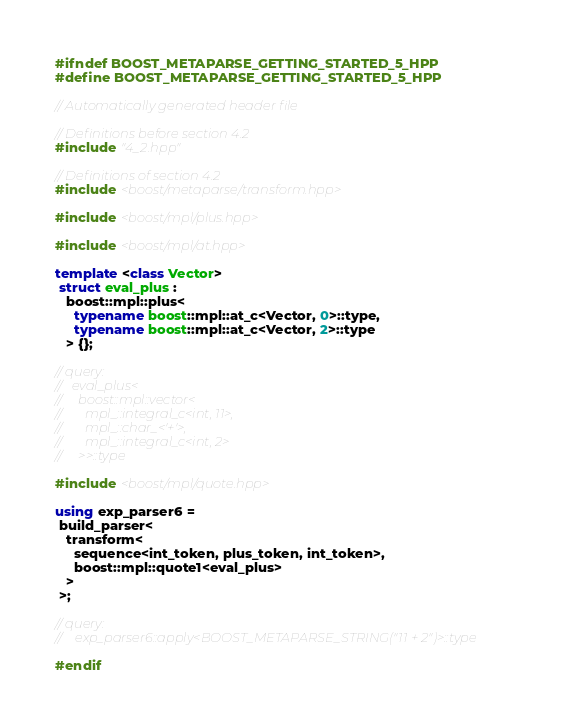Convert code to text. <code><loc_0><loc_0><loc_500><loc_500><_C++_>#ifndef BOOST_METAPARSE_GETTING_STARTED_5_HPP
#define BOOST_METAPARSE_GETTING_STARTED_5_HPP

// Automatically generated header file

// Definitions before section 4.2
#include "4_2.hpp"

// Definitions of section 4.2
#include <boost/metaparse/transform.hpp>

#include <boost/mpl/plus.hpp>

#include <boost/mpl/at.hpp>

template <class Vector> 
 struct eval_plus : 
   boost::mpl::plus< 
     typename boost::mpl::at_c<Vector, 0>::type, 
     typename boost::mpl::at_c<Vector, 2>::type 
   > {};

// query:
//   eval_plus< 
//     boost::mpl::vector< 
//       mpl_::integral_c<int, 11>, 
//       mpl_::char_<'+'>, 
//       mpl_::integral_c<int, 2> 
//     >>::type

#include <boost/mpl/quote.hpp>

using exp_parser6 = 
 build_parser< 
   transform< 
     sequence<int_token, plus_token, int_token>, 
     boost::mpl::quote1<eval_plus> 
   > 
 >;

// query:
//    exp_parser6::apply<BOOST_METAPARSE_STRING("11 + 2")>::type

#endif

</code> 